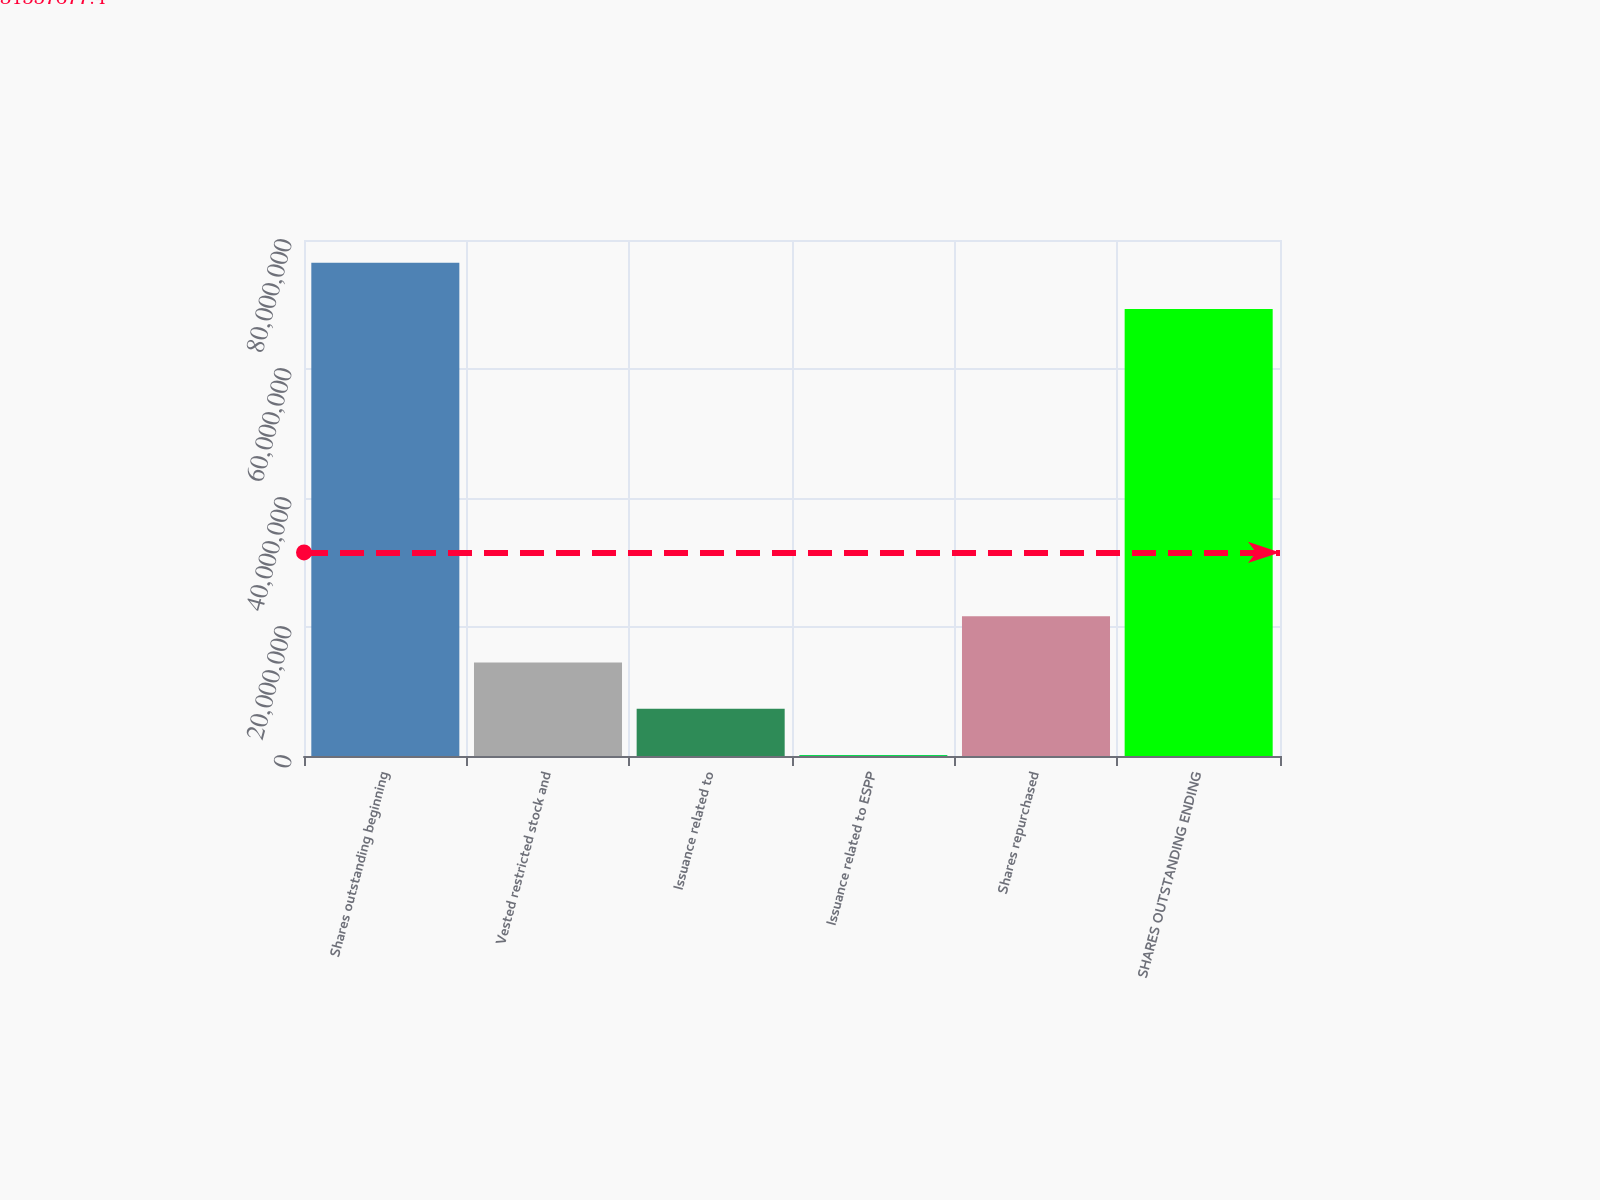<chart> <loc_0><loc_0><loc_500><loc_500><bar_chart><fcel>Shares outstanding beginning<fcel>Vested restricted stock and<fcel>Issuance related to<fcel>Issuance related to ESPP<fcel>Shares repurchased<fcel>SHARES OUTSTANDING ENDING<nl><fcel>7.64682e+07<fcel>1.44789e+07<fcel>7.31024e+06<fcel>141576<fcel>2.16476e+07<fcel>6.92996e+07<nl></chart> 